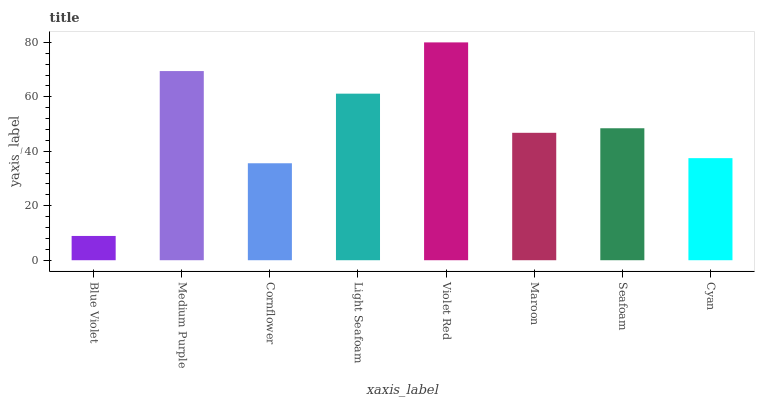Is Medium Purple the minimum?
Answer yes or no. No. Is Medium Purple the maximum?
Answer yes or no. No. Is Medium Purple greater than Blue Violet?
Answer yes or no. Yes. Is Blue Violet less than Medium Purple?
Answer yes or no. Yes. Is Blue Violet greater than Medium Purple?
Answer yes or no. No. Is Medium Purple less than Blue Violet?
Answer yes or no. No. Is Seafoam the high median?
Answer yes or no. Yes. Is Maroon the low median?
Answer yes or no. Yes. Is Maroon the high median?
Answer yes or no. No. Is Cornflower the low median?
Answer yes or no. No. 